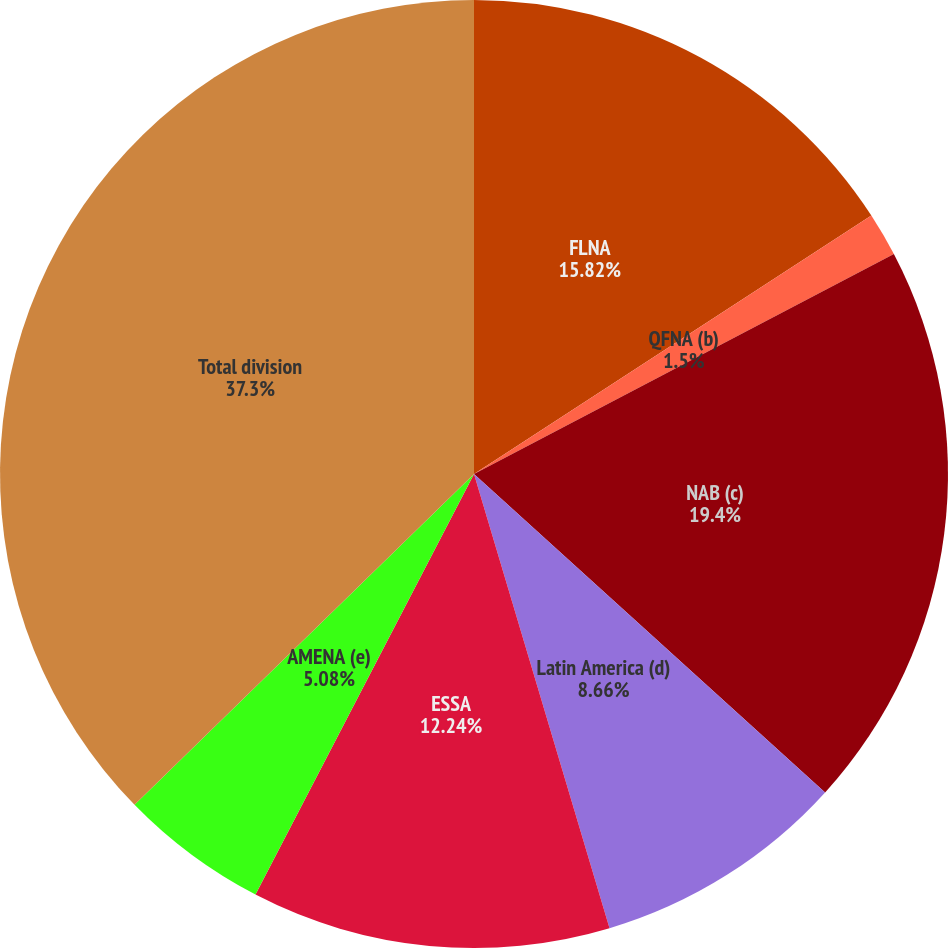<chart> <loc_0><loc_0><loc_500><loc_500><pie_chart><fcel>FLNA<fcel>QFNA (b)<fcel>NAB (c)<fcel>Latin America (d)<fcel>ESSA<fcel>AMENA (e)<fcel>Total division<nl><fcel>15.82%<fcel>1.5%<fcel>19.4%<fcel>8.66%<fcel>12.24%<fcel>5.08%<fcel>37.29%<nl></chart> 